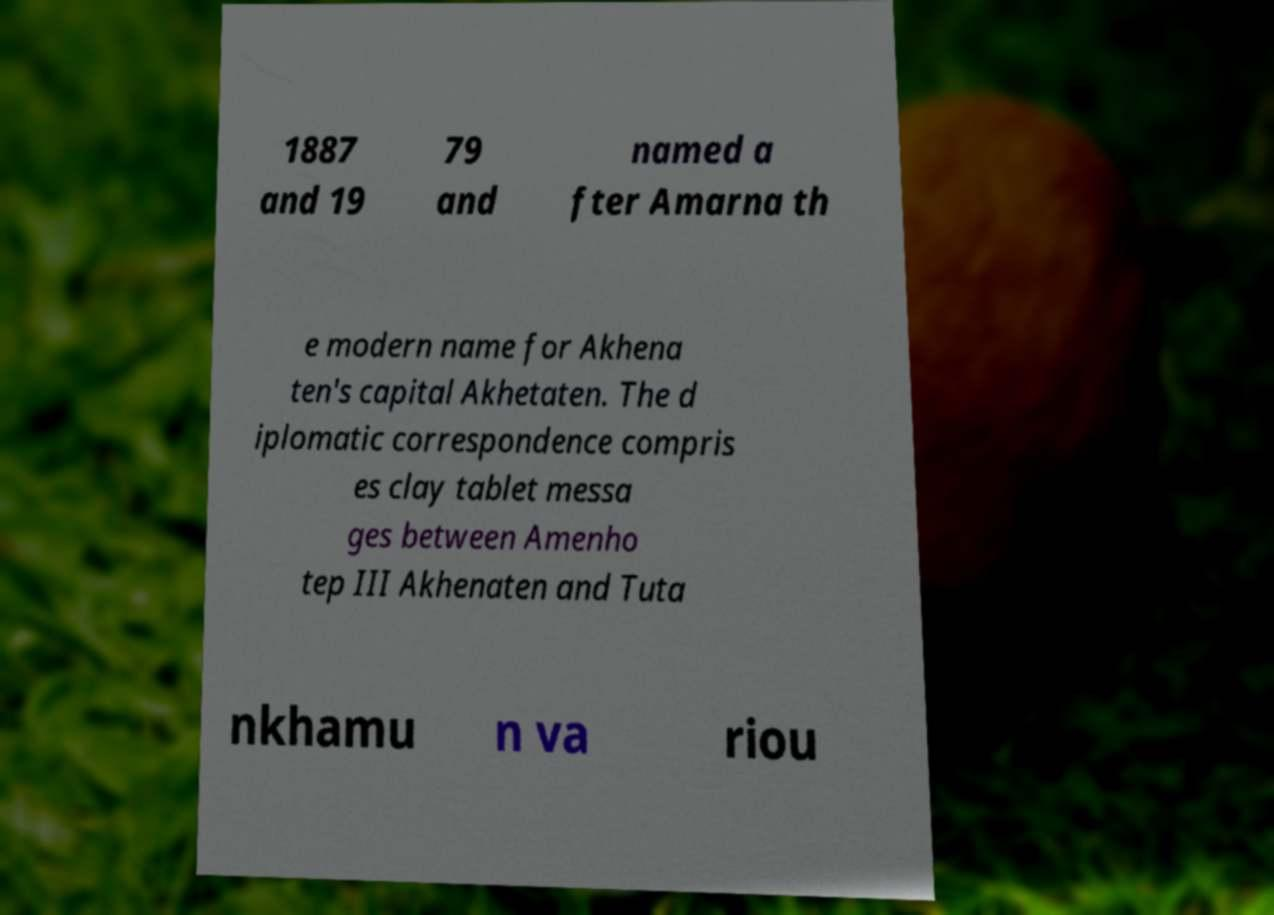Could you assist in decoding the text presented in this image and type it out clearly? 1887 and 19 79 and named a fter Amarna th e modern name for Akhena ten's capital Akhetaten. The d iplomatic correspondence compris es clay tablet messa ges between Amenho tep III Akhenaten and Tuta nkhamu n va riou 